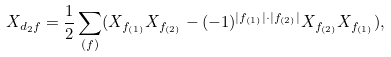<formula> <loc_0><loc_0><loc_500><loc_500>X _ { d _ { 2 } f } = \frac { 1 } { 2 } \sum _ { ( f ) } ( X _ { f _ { ( 1 ) } } X _ { f _ { ( 2 ) } } - ( - 1 ) ^ { | f _ { ( 1 ) } | \cdot | f _ { ( 2 ) } | } X _ { f _ { ( 2 ) } } X _ { f _ { ( 1 ) } } ) ,</formula> 